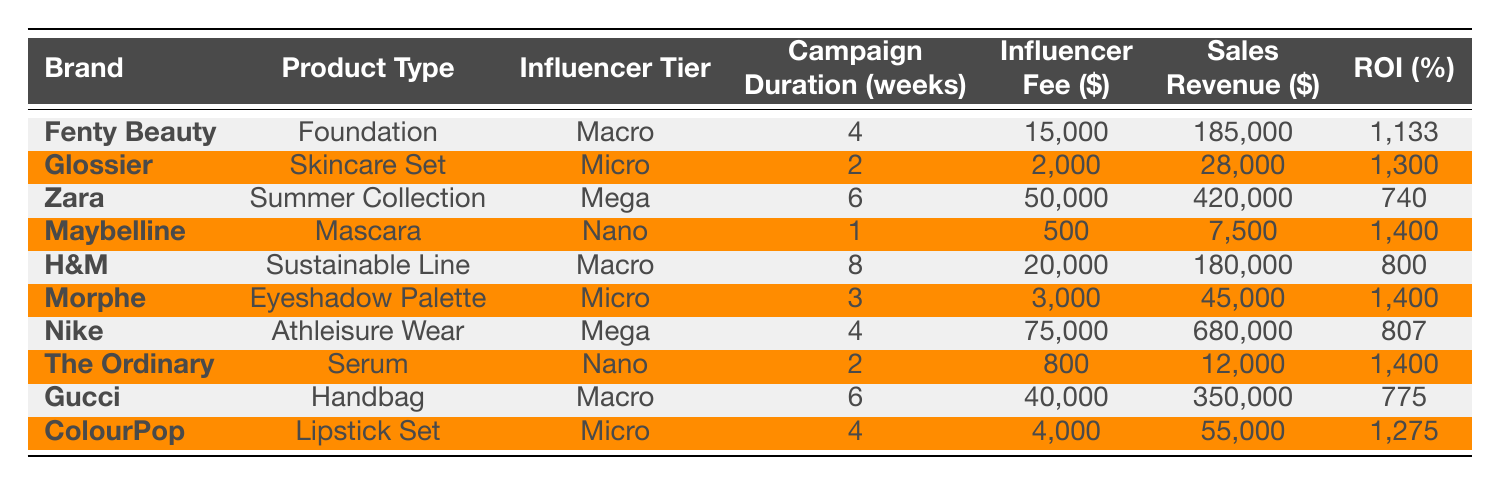What is the highest ROI achieved by a brand in this table? Looking at the ROI column, the highest value is 1,400%, which occurs for two brands: Maybelline and The Ordinary.
Answer: 1400% Which product has the lowest sales revenue? By reviewing the Sales Revenue column, Maybelline's Mascara has the lowest sales revenue at $7,500.
Answer: $7500 What is the average influencer fee for campaigns listed in the table? The influencer fees are 15,000, 2,000, 50,000, 500, 20,000, 3,000, 75,000, 800, 40,000, and 4,000. Summing these gives 210,300. There are 10 campaigns, so the average fee is 210,300 / 10 = 21,030.
Answer: 21030 Did any campaigns have a higher sales revenue than the influencer fee? Checking each row, yes, all campaigns had sales revenue higher than the influencer fees since the smallest sales revenue ($7,500) is greater than the smallest influencer fee ($500).
Answer: Yes What are the total sales revenues for all Macro tier influencers? The sales revenues for Macro tier influencers (Fenty Beauty, H&M, Gucci) are 185,000, 180,000, and 350,000 respectively. Summing these gives 185,000 + 180,000 + 350,000 = 715,000.
Answer: 715000 How many campaigns lasted longer than 4 weeks? The campaigns that last longer than 4 weeks are Zara (6 weeks), H&M (8 weeks), and Nike (4 weeks). This amounts to a total of 3 campaigns.
Answer: 3 Is there a correlation between influencer tier and ROI? While the data shows a variation in ROI across influencer tiers, a detailed analysis of the data would be needed to determine a statistical correlation. By observing, it's noted that Nano and Micro tiers often have higher ROI percentages.
Answer: No clear correlation What is the total ROI of all campaigns combined? We sum the ROI values: 1133 + 1300 + 740 + 1400 + 800 + 1400 + 807 + 1400 + 775 + 1275 = 10030.
Answer: 10030 